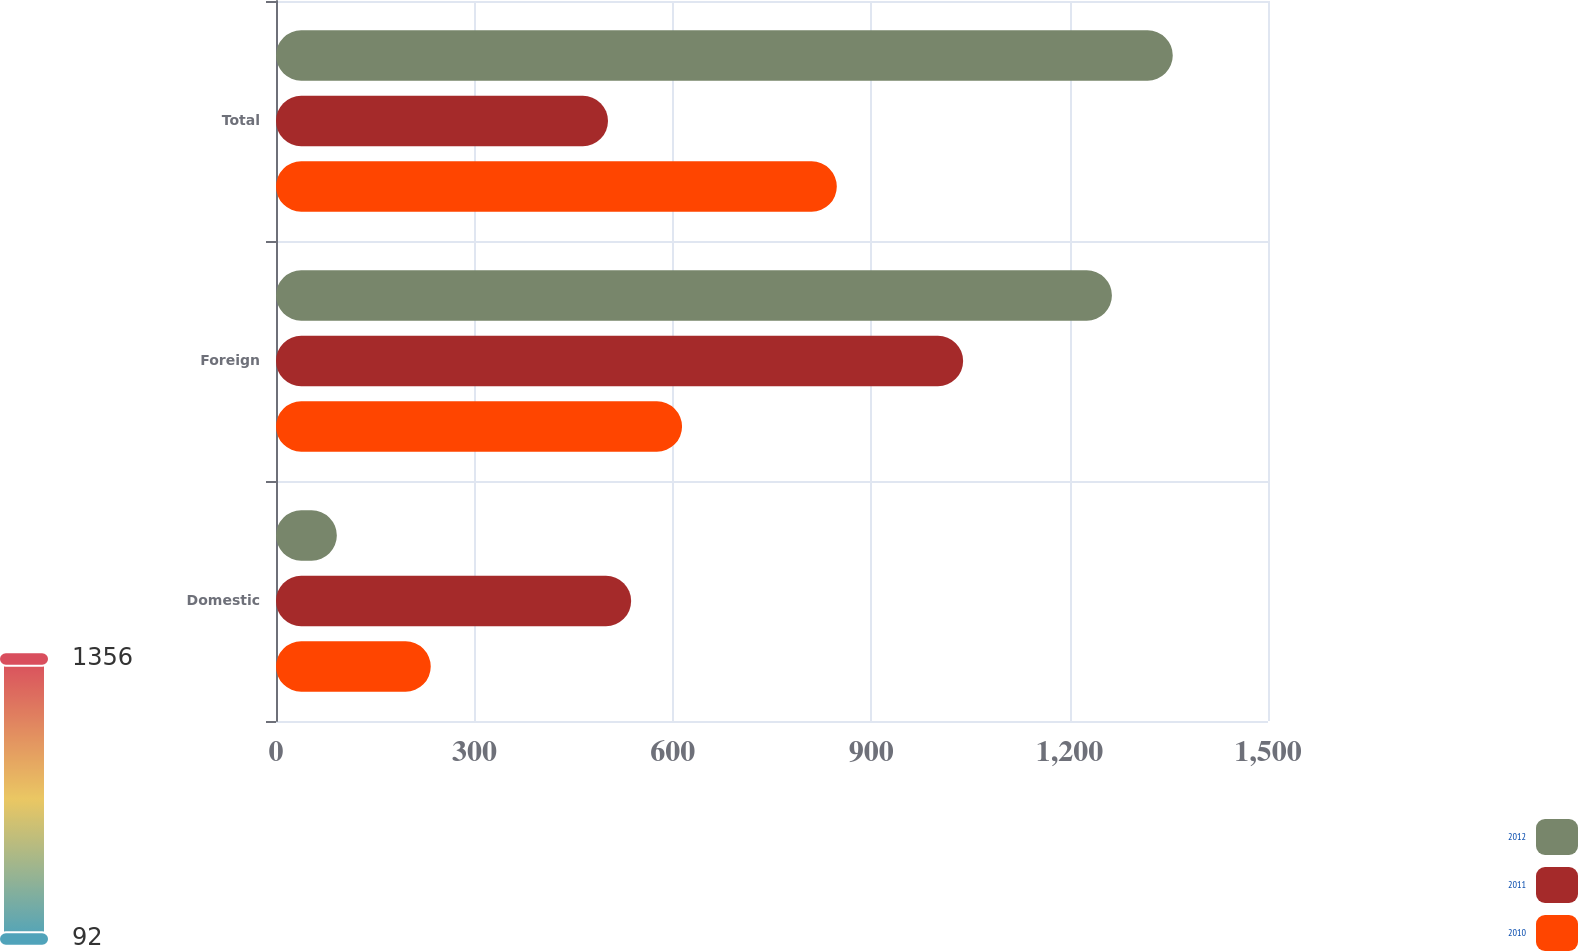Convert chart. <chart><loc_0><loc_0><loc_500><loc_500><stacked_bar_chart><ecel><fcel>Domestic<fcel>Foreign<fcel>Total<nl><fcel>2012<fcel>92<fcel>1264<fcel>1356<nl><fcel>2011<fcel>537<fcel>1039<fcel>502<nl><fcel>2010<fcel>234<fcel>614<fcel>848<nl></chart> 